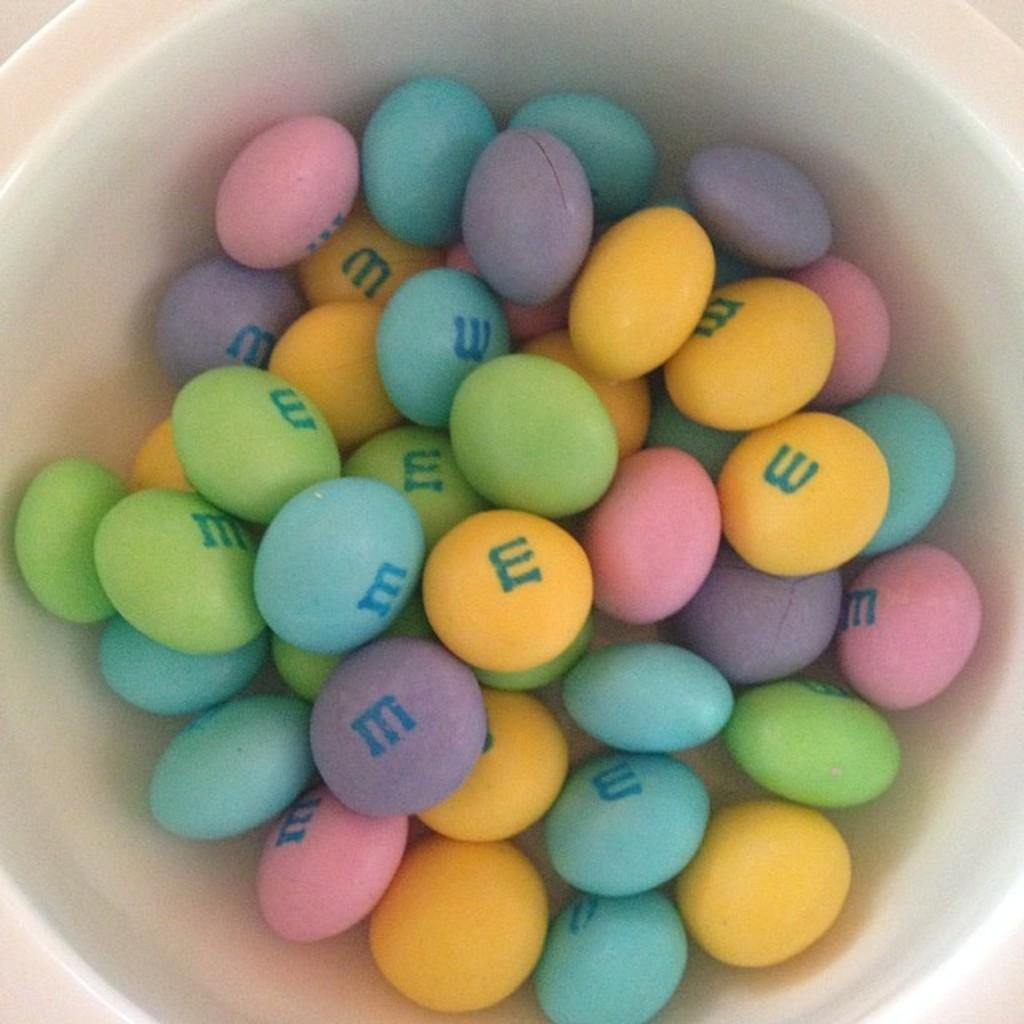What color is the bowl in the image? The bowl in the image is white. What type of candy is in the bowl? There are M&Ms in the bowl. Can you describe the colors of the M&Ms? The M&Ms in the bowl are blue, green, yellow, pink, and violet in color. Is there any meat being served in the image? No, there is no meat present in the image. Is this a birthday party scene? The image does not provide any information about a birthday party, so we cannot determine if it is a birthday party scene. 